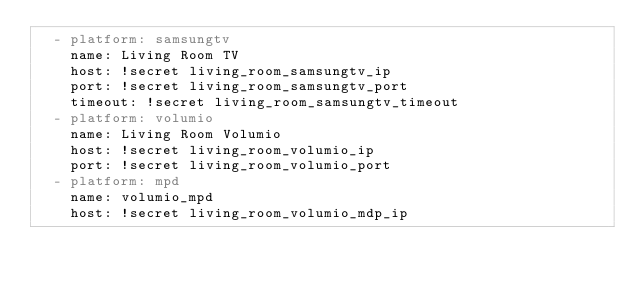<code> <loc_0><loc_0><loc_500><loc_500><_YAML_>  - platform: samsungtv
    name: Living Room TV
    host: !secret living_room_samsungtv_ip
    port: !secret living_room_samsungtv_port
    timeout: !secret living_room_samsungtv_timeout
  - platform: volumio
    name: Living Room Volumio
    host: !secret living_room_volumio_ip
    port: !secret living_room_volumio_port
  - platform: mpd
    name: volumio_mpd
    host: !secret living_room_volumio_mdp_ip</code> 